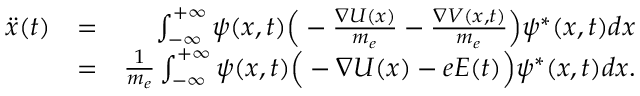Convert formula to latex. <formula><loc_0><loc_0><loc_500><loc_500>\begin{array} { r l r } { \ddot { x } ( t ) } & { = } & { \int _ { - \infty } ^ { + \infty } \psi ( x , t ) \left ( - \frac { \nabla U ( x ) } { m _ { e } } - \frac { \nabla V ( x , t ) } { m _ { e } } \right ) \psi ^ { * } ( x , t ) d x } \\ & { = } & { \frac { 1 } { m _ { e } } \int _ { - \infty } ^ { + \infty } \psi ( x , t ) \left ( - \nabla U ( x ) - e E ( t ) \right ) \psi ^ { * } ( x , t ) d x . } \end{array}</formula> 